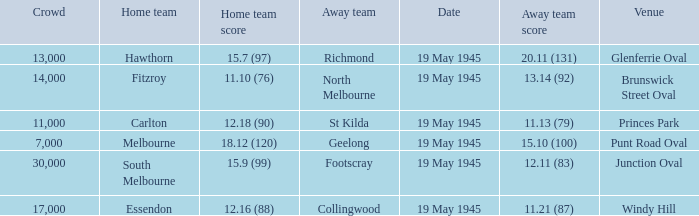On which date was Essendon the home team? 19 May 1945. 